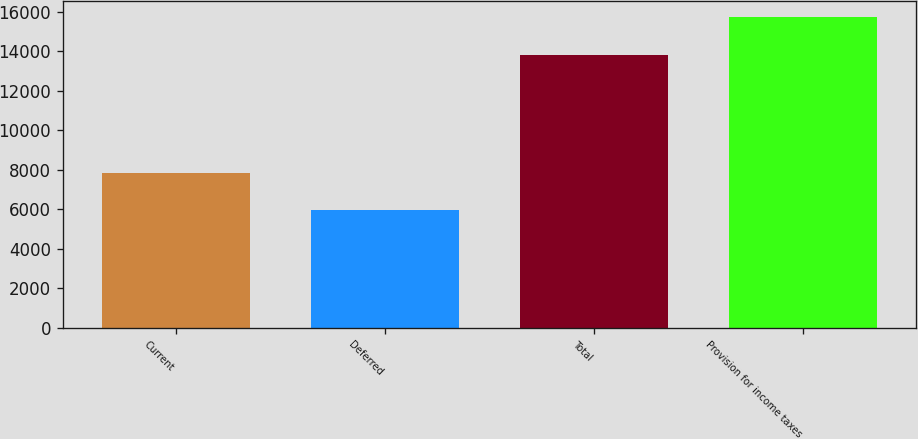Convert chart. <chart><loc_0><loc_0><loc_500><loc_500><bar_chart><fcel>Current<fcel>Deferred<fcel>Total<fcel>Provision for income taxes<nl><fcel>7842<fcel>5980<fcel>13822<fcel>15738<nl></chart> 